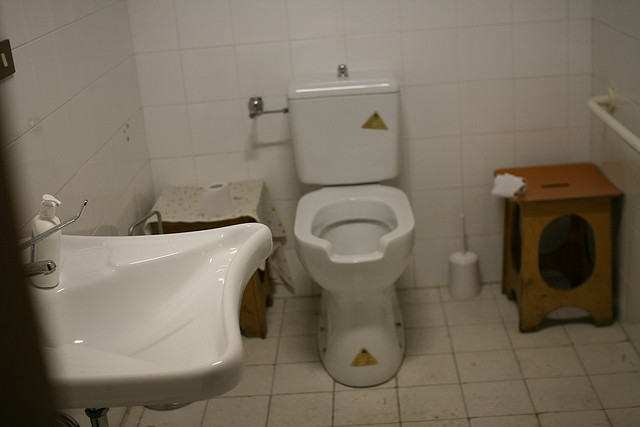Can you comment on the overall condition of the bathroom? The bathroom appears to be in a used condition with some level of untidiness. There seems to be a bit of clutter on the floor and the shelving unit, and toiletries are scattered, suggesting the space is actively used. 